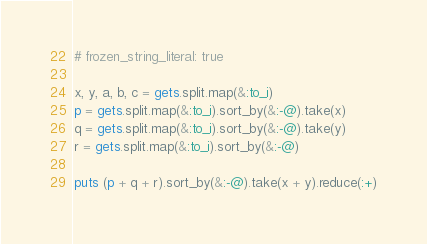<code> <loc_0><loc_0><loc_500><loc_500><_Ruby_># frozen_string_literal: true

x, y, a, b, c = gets.split.map(&:to_i)
p = gets.split.map(&:to_i).sort_by(&:-@).take(x)
q = gets.split.map(&:to_i).sort_by(&:-@).take(y)
r = gets.split.map(&:to_i).sort_by(&:-@)

puts (p + q + r).sort_by(&:-@).take(x + y).reduce(:+)
</code> 